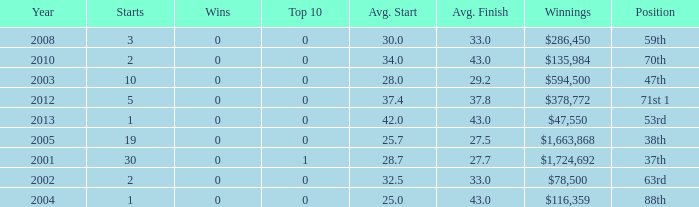How many wins for average start less than 25? 0.0. 